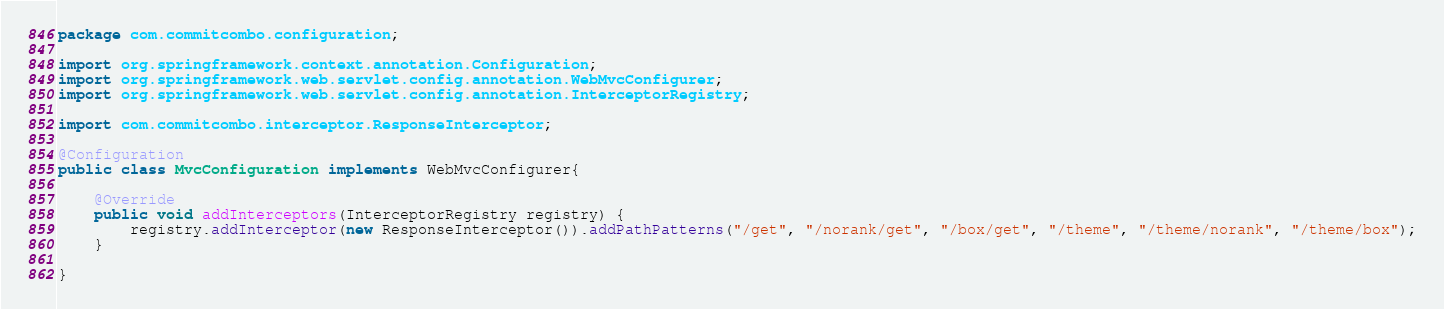<code> <loc_0><loc_0><loc_500><loc_500><_Java_>package com.commitcombo.configuration;

import org.springframework.context.annotation.Configuration;
import org.springframework.web.servlet.config.annotation.WebMvcConfigurer;
import org.springframework.web.servlet.config.annotation.InterceptorRegistry;

import com.commitcombo.interceptor.ResponseInterceptor;

@Configuration
public class MvcConfiguration implements WebMvcConfigurer{
	
	@Override
	public void addInterceptors(InterceptorRegistry registry) {
		registry.addInterceptor(new ResponseInterceptor()).addPathPatterns("/get", "/norank/get", "/box/get", "/theme", "/theme/norank", "/theme/box");
	}
	
}</code> 